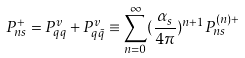<formula> <loc_0><loc_0><loc_500><loc_500>P _ { n s } ^ { + } = P _ { q q } ^ { v } + P _ { q \bar { q } } ^ { v } \equiv \sum _ { n = 0 } ^ { \infty } ( \frac { \alpha _ { s } } { 4 \pi } ) ^ { n + 1 } P _ { n s } ^ { ( n ) + }</formula> 